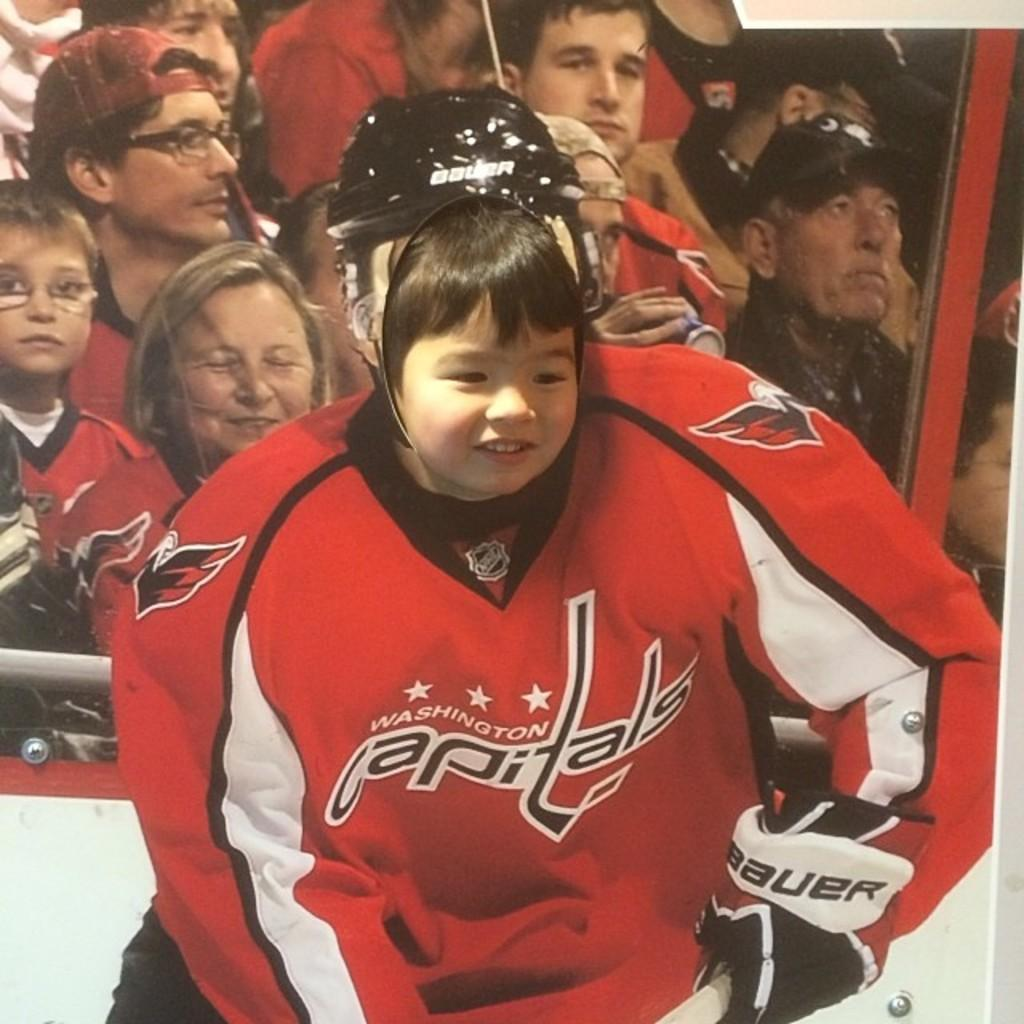<image>
Share a concise interpretation of the image provided. A little girl's head is placed on top of a Capital's hockey jersey. 